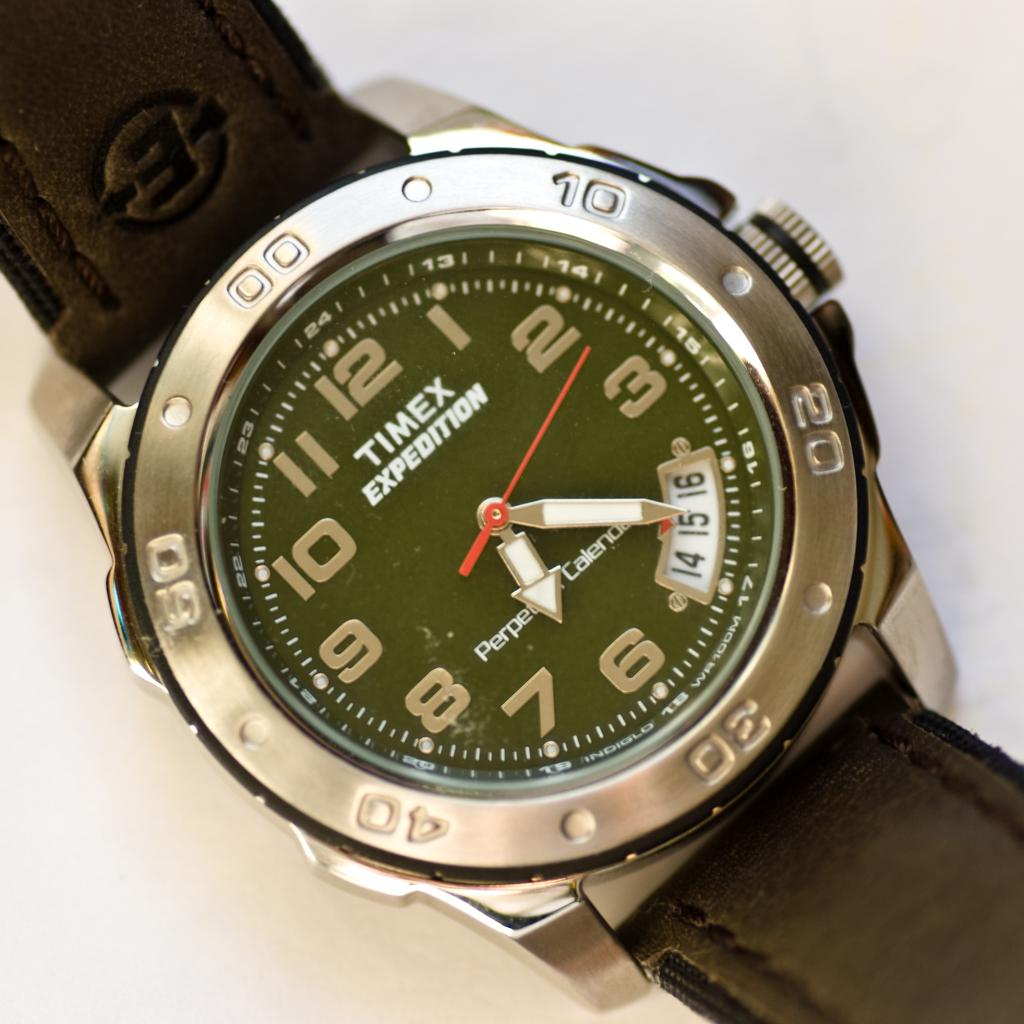<image>
Describe the image concisely. A Timex watch with a brown leather band that shows 6:20. 